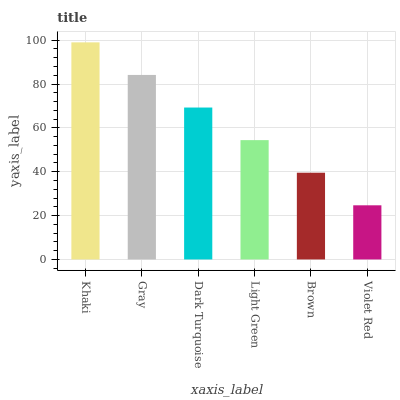Is Violet Red the minimum?
Answer yes or no. Yes. Is Khaki the maximum?
Answer yes or no. Yes. Is Gray the minimum?
Answer yes or no. No. Is Gray the maximum?
Answer yes or no. No. Is Khaki greater than Gray?
Answer yes or no. Yes. Is Gray less than Khaki?
Answer yes or no. Yes. Is Gray greater than Khaki?
Answer yes or no. No. Is Khaki less than Gray?
Answer yes or no. No. Is Dark Turquoise the high median?
Answer yes or no. Yes. Is Light Green the low median?
Answer yes or no. Yes. Is Brown the high median?
Answer yes or no. No. Is Khaki the low median?
Answer yes or no. No. 